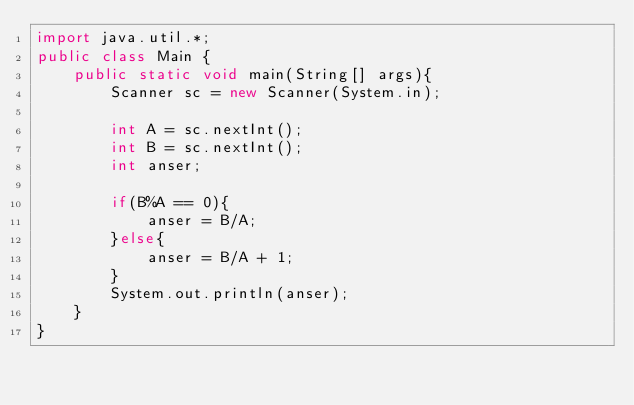<code> <loc_0><loc_0><loc_500><loc_500><_Java_>import java.util.*;
public class Main {
	public static void main(String[] args){
		Scanner sc = new Scanner(System.in);
		
      	int A = sc.nextInt();
      	int B = sc.nextInt();
      	int anser;

		if(B%A == 0){
          	anser = B/A;
        }else{
          	anser = B/A + 1;
        }
      	System.out.println(anser);
	}
}</code> 